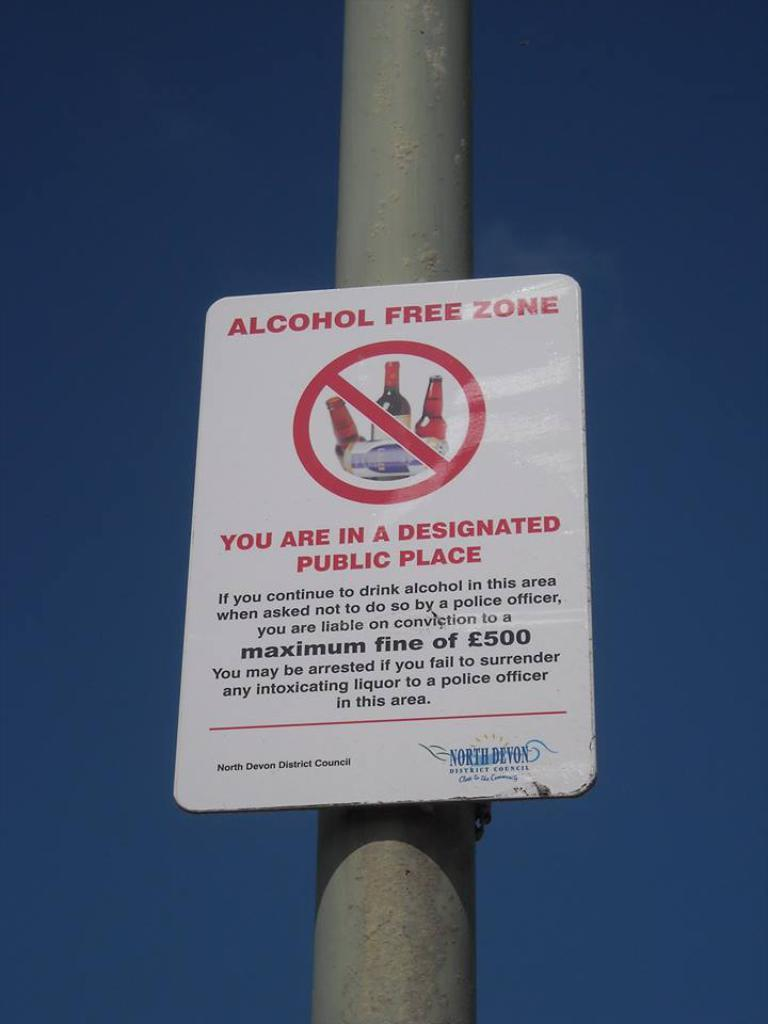<image>
Provide a brief description of the given image. A sign on a pole that informs the area is a Alcohol free zone. 